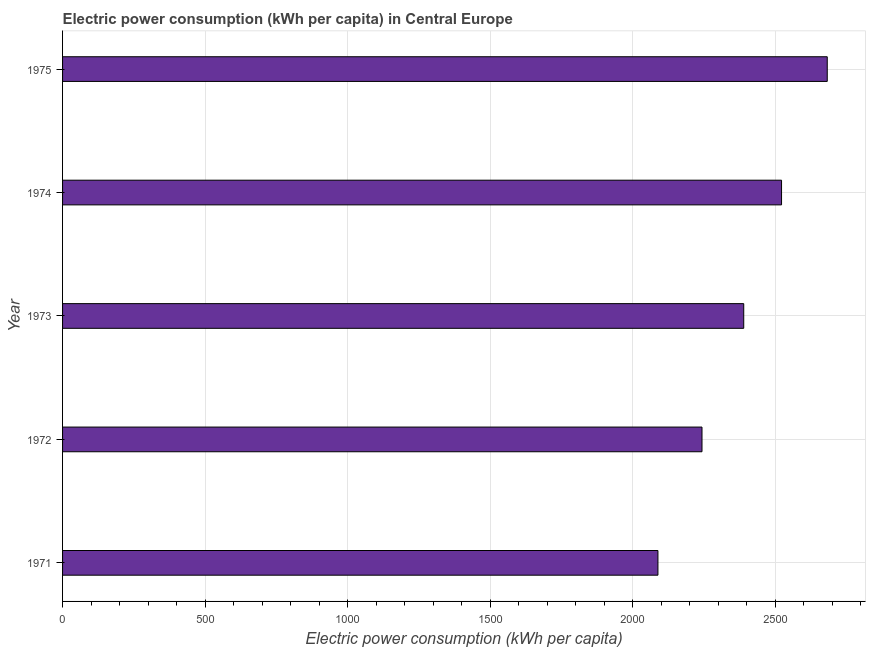Does the graph contain grids?
Make the answer very short. Yes. What is the title of the graph?
Your answer should be very brief. Electric power consumption (kWh per capita) in Central Europe. What is the label or title of the X-axis?
Offer a terse response. Electric power consumption (kWh per capita). What is the electric power consumption in 1971?
Your answer should be compact. 2088.95. Across all years, what is the maximum electric power consumption?
Make the answer very short. 2683.05. Across all years, what is the minimum electric power consumption?
Provide a succinct answer. 2088.95. In which year was the electric power consumption maximum?
Make the answer very short. 1975. In which year was the electric power consumption minimum?
Offer a very short reply. 1971. What is the sum of the electric power consumption?
Your answer should be very brief. 1.19e+04. What is the difference between the electric power consumption in 1972 and 1973?
Ensure brevity in your answer.  -146.45. What is the average electric power consumption per year?
Offer a very short reply. 2385.64. What is the median electric power consumption?
Offer a very short reply. 2389.99. What is the ratio of the electric power consumption in 1972 to that in 1975?
Provide a short and direct response. 0.84. What is the difference between the highest and the second highest electric power consumption?
Ensure brevity in your answer.  160.37. Is the sum of the electric power consumption in 1973 and 1974 greater than the maximum electric power consumption across all years?
Your answer should be compact. Yes. What is the difference between the highest and the lowest electric power consumption?
Ensure brevity in your answer.  594.09. How many bars are there?
Offer a terse response. 5. Are all the bars in the graph horizontal?
Provide a short and direct response. Yes. What is the Electric power consumption (kWh per capita) in 1971?
Give a very brief answer. 2088.95. What is the Electric power consumption (kWh per capita) in 1972?
Ensure brevity in your answer.  2243.54. What is the Electric power consumption (kWh per capita) in 1973?
Offer a very short reply. 2389.99. What is the Electric power consumption (kWh per capita) in 1974?
Provide a succinct answer. 2522.68. What is the Electric power consumption (kWh per capita) of 1975?
Your answer should be very brief. 2683.05. What is the difference between the Electric power consumption (kWh per capita) in 1971 and 1972?
Ensure brevity in your answer.  -154.58. What is the difference between the Electric power consumption (kWh per capita) in 1971 and 1973?
Give a very brief answer. -301.03. What is the difference between the Electric power consumption (kWh per capita) in 1971 and 1974?
Your response must be concise. -433.73. What is the difference between the Electric power consumption (kWh per capita) in 1971 and 1975?
Provide a succinct answer. -594.09. What is the difference between the Electric power consumption (kWh per capita) in 1972 and 1973?
Keep it short and to the point. -146.45. What is the difference between the Electric power consumption (kWh per capita) in 1972 and 1974?
Provide a succinct answer. -279.14. What is the difference between the Electric power consumption (kWh per capita) in 1972 and 1975?
Offer a terse response. -439.51. What is the difference between the Electric power consumption (kWh per capita) in 1973 and 1974?
Keep it short and to the point. -132.69. What is the difference between the Electric power consumption (kWh per capita) in 1973 and 1975?
Offer a terse response. -293.06. What is the difference between the Electric power consumption (kWh per capita) in 1974 and 1975?
Give a very brief answer. -160.37. What is the ratio of the Electric power consumption (kWh per capita) in 1971 to that in 1973?
Provide a short and direct response. 0.87. What is the ratio of the Electric power consumption (kWh per capita) in 1971 to that in 1974?
Your answer should be very brief. 0.83. What is the ratio of the Electric power consumption (kWh per capita) in 1971 to that in 1975?
Give a very brief answer. 0.78. What is the ratio of the Electric power consumption (kWh per capita) in 1972 to that in 1973?
Your response must be concise. 0.94. What is the ratio of the Electric power consumption (kWh per capita) in 1972 to that in 1974?
Your response must be concise. 0.89. What is the ratio of the Electric power consumption (kWh per capita) in 1972 to that in 1975?
Give a very brief answer. 0.84. What is the ratio of the Electric power consumption (kWh per capita) in 1973 to that in 1974?
Your answer should be very brief. 0.95. What is the ratio of the Electric power consumption (kWh per capita) in 1973 to that in 1975?
Give a very brief answer. 0.89. What is the ratio of the Electric power consumption (kWh per capita) in 1974 to that in 1975?
Give a very brief answer. 0.94. 